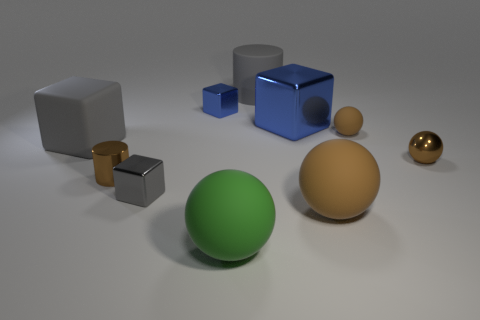Subtract all blue cylinders. How many brown balls are left? 3 Subtract all small rubber spheres. How many spheres are left? 3 Subtract 2 blocks. How many blocks are left? 2 Subtract all green balls. How many balls are left? 3 Subtract all yellow spheres. Subtract all blue cubes. How many spheres are left? 4 Subtract all blocks. How many objects are left? 6 Subtract 0 blue balls. How many objects are left? 10 Subtract all brown matte spheres. Subtract all big matte cylinders. How many objects are left? 7 Add 1 brown spheres. How many brown spheres are left? 4 Add 6 green spheres. How many green spheres exist? 7 